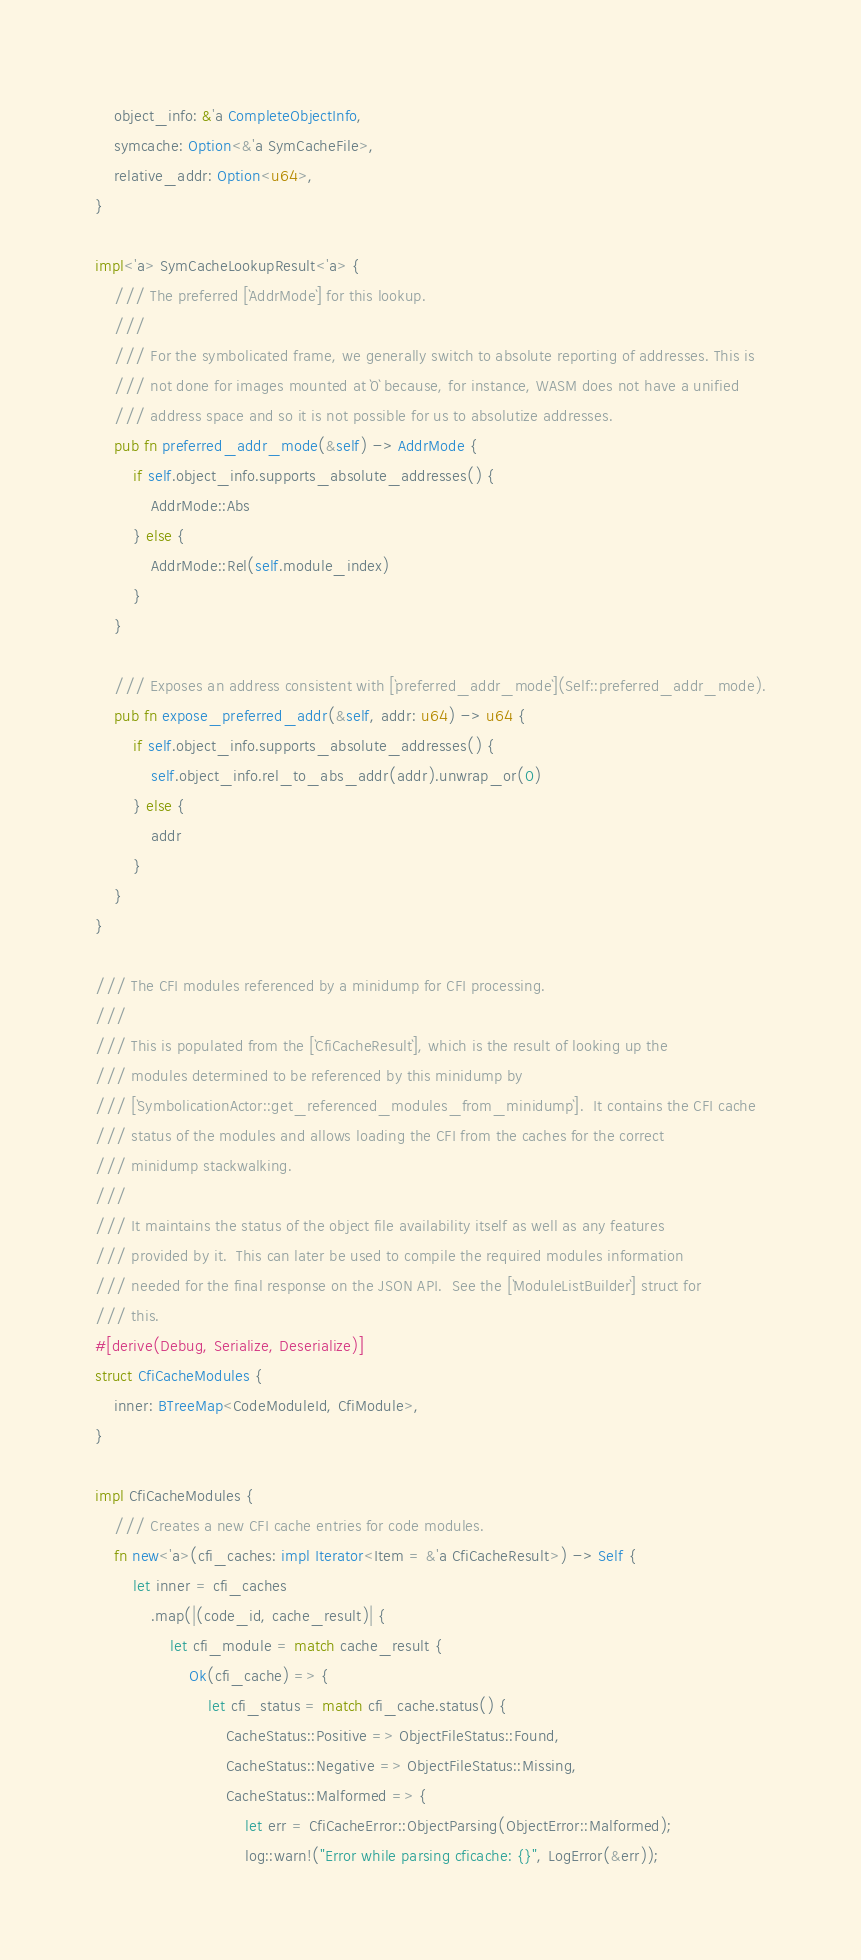<code> <loc_0><loc_0><loc_500><loc_500><_Rust_>    object_info: &'a CompleteObjectInfo,
    symcache: Option<&'a SymCacheFile>,
    relative_addr: Option<u64>,
}

impl<'a> SymCacheLookupResult<'a> {
    /// The preferred [`AddrMode`] for this lookup.
    ///
    /// For the symbolicated frame, we generally switch to absolute reporting of addresses. This is
    /// not done for images mounted at `0` because, for instance, WASM does not have a unified
    /// address space and so it is not possible for us to absolutize addresses.
    pub fn preferred_addr_mode(&self) -> AddrMode {
        if self.object_info.supports_absolute_addresses() {
            AddrMode::Abs
        } else {
            AddrMode::Rel(self.module_index)
        }
    }

    /// Exposes an address consistent with [`preferred_addr_mode`](Self::preferred_addr_mode).
    pub fn expose_preferred_addr(&self, addr: u64) -> u64 {
        if self.object_info.supports_absolute_addresses() {
            self.object_info.rel_to_abs_addr(addr).unwrap_or(0)
        } else {
            addr
        }
    }
}

/// The CFI modules referenced by a minidump for CFI processing.
///
/// This is populated from the [`CfiCacheResult`], which is the result of looking up the
/// modules determined to be referenced by this minidump by
/// [`SymbolicationActor::get_referenced_modules_from_minidump`].  It contains the CFI cache
/// status of the modules and allows loading the CFI from the caches for the correct
/// minidump stackwalking.
///
/// It maintains the status of the object file availability itself as well as any features
/// provided by it.  This can later be used to compile the required modules information
/// needed for the final response on the JSON API.  See the [`ModuleListBuilder`] struct for
/// this.
#[derive(Debug, Serialize, Deserialize)]
struct CfiCacheModules {
    inner: BTreeMap<CodeModuleId, CfiModule>,
}

impl CfiCacheModules {
    /// Creates a new CFI cache entries for code modules.
    fn new<'a>(cfi_caches: impl Iterator<Item = &'a CfiCacheResult>) -> Self {
        let inner = cfi_caches
            .map(|(code_id, cache_result)| {
                let cfi_module = match cache_result {
                    Ok(cfi_cache) => {
                        let cfi_status = match cfi_cache.status() {
                            CacheStatus::Positive => ObjectFileStatus::Found,
                            CacheStatus::Negative => ObjectFileStatus::Missing,
                            CacheStatus::Malformed => {
                                let err = CfiCacheError::ObjectParsing(ObjectError::Malformed);
                                log::warn!("Error while parsing cficache: {}", LogError(&err));</code> 